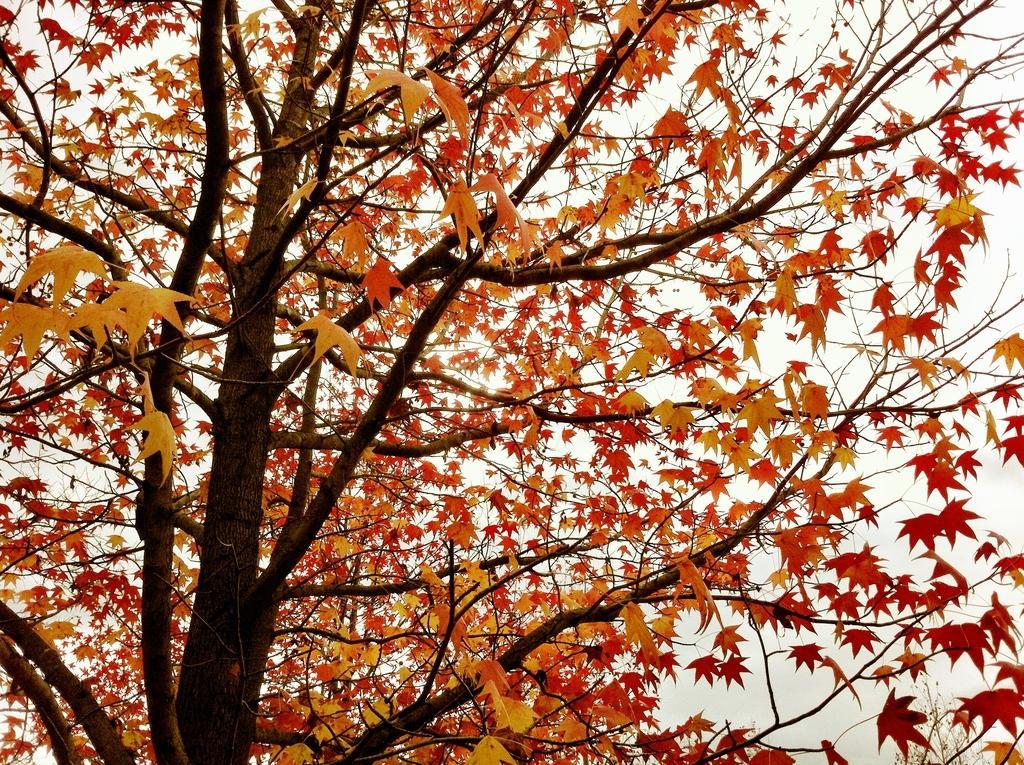Describe this image in one or two sentences. In this image I can see a tree with maple leaves. And there is a white background. 